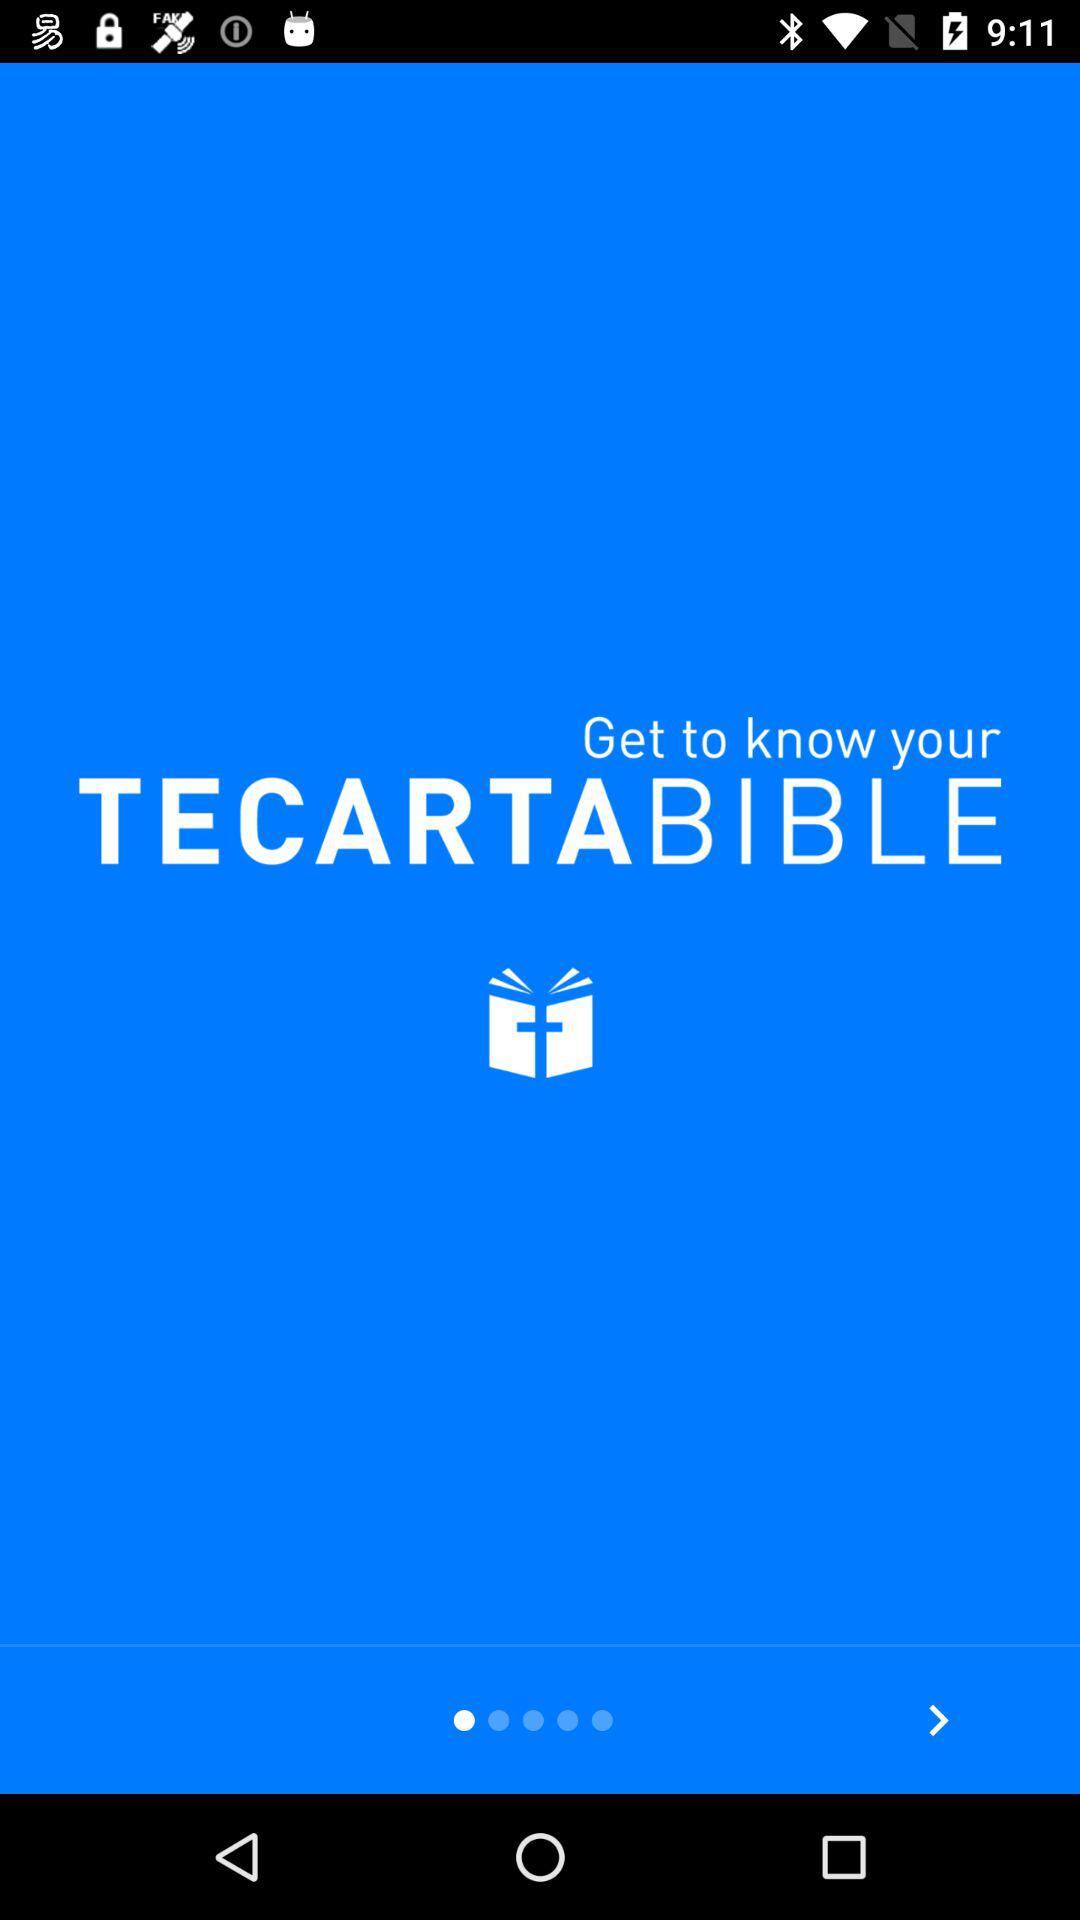What is the version of this application?
When the provided information is insufficient, respond with <no answer>. <no answer> 